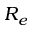<formula> <loc_0><loc_0><loc_500><loc_500>R _ { e }</formula> 